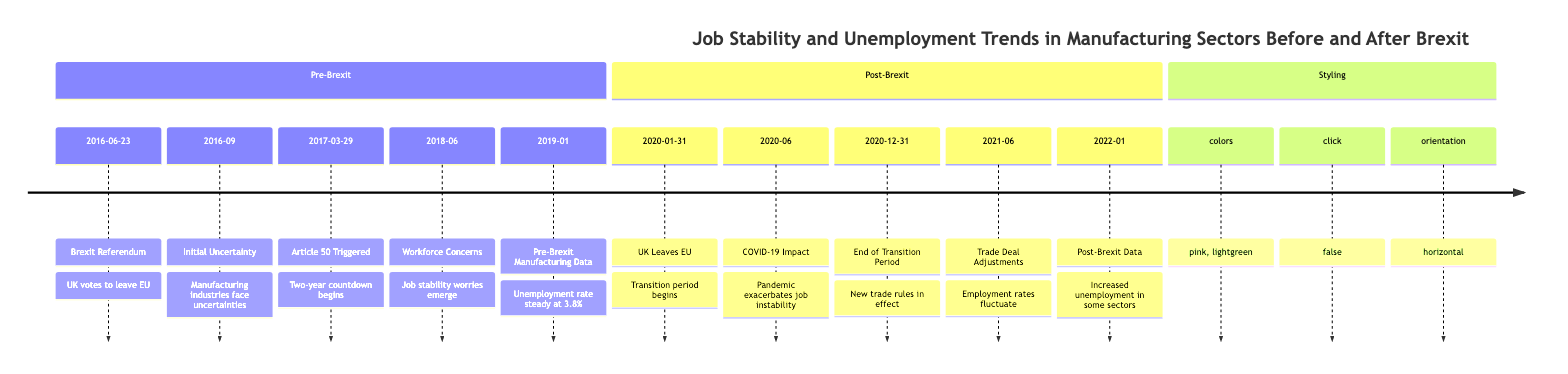What date did the UK officially leave the EU? The timeline indicates that the UK leaves the EU on January 31, 2020, which is explicitly mentioned in the event description.
Answer: January 31, 2020 What was the unemployment rate in manufacturing before Brexit as of January 2019? The timeline states that the unemployment rate in manufacturing was steady at around 3.8% as of January 2019, directly capturing the information from that date's event description.
Answer: 3.8% What significant event occurred on June 23, 2016? The event listed on that date is the Brexit Referendum, where the UK voted to leave the EU, making it a pivotal moment in the timeline.
Answer: Brexit Referendum How did COVID-19 impact job stability in manufacturing? According to the timeline, the COVID-19 pandemic exacerbated job instability in the manufacturing sector, which compounded the issues arising from Brexit. This relationship highlights the combined difficulties faced by workers.
Answer: Exacerbated job instability Which manufacturing sectors experienced increased unemployment post-Brexit? The timeline states that automotive and aerospace industries were hardest hit, suggesting they faced the most significant increases in unemployment after Brexit.
Answer: Automotive and aerospace industries What happened on March 29, 2017? The timeline notes that on this date, the UK formally triggered Article 50, initiating a two-year countdown to Brexit, marking an important step in the departure process.
Answer: Article 50 Triggered Which event directly followed the end of the transition period on December 31, 2020? After the end of the transition period, manufacturers began to report disruptions due to changes in supply chains, as indicated in the subsequent event on the timeline. This shows the direct consequence of that event.
Answer: Supply chain disruptions What was the trend in manufacturing unemployment reported in January 2022? The timeline indicates that statistics showed increased unemployment rates in certain manufacturing sectors, specifically mentioning that some sectors were hit hard, reflecting negative trends as of that date.
Answer: Increased unemployment rates What was the primary concern for workers in June 2018? Reports in June 2018 highlighted workforce concerns, specifically over job stability among factory workers, elucidating the uncertainties they faced during this period.
Answer: Job stability concerns 